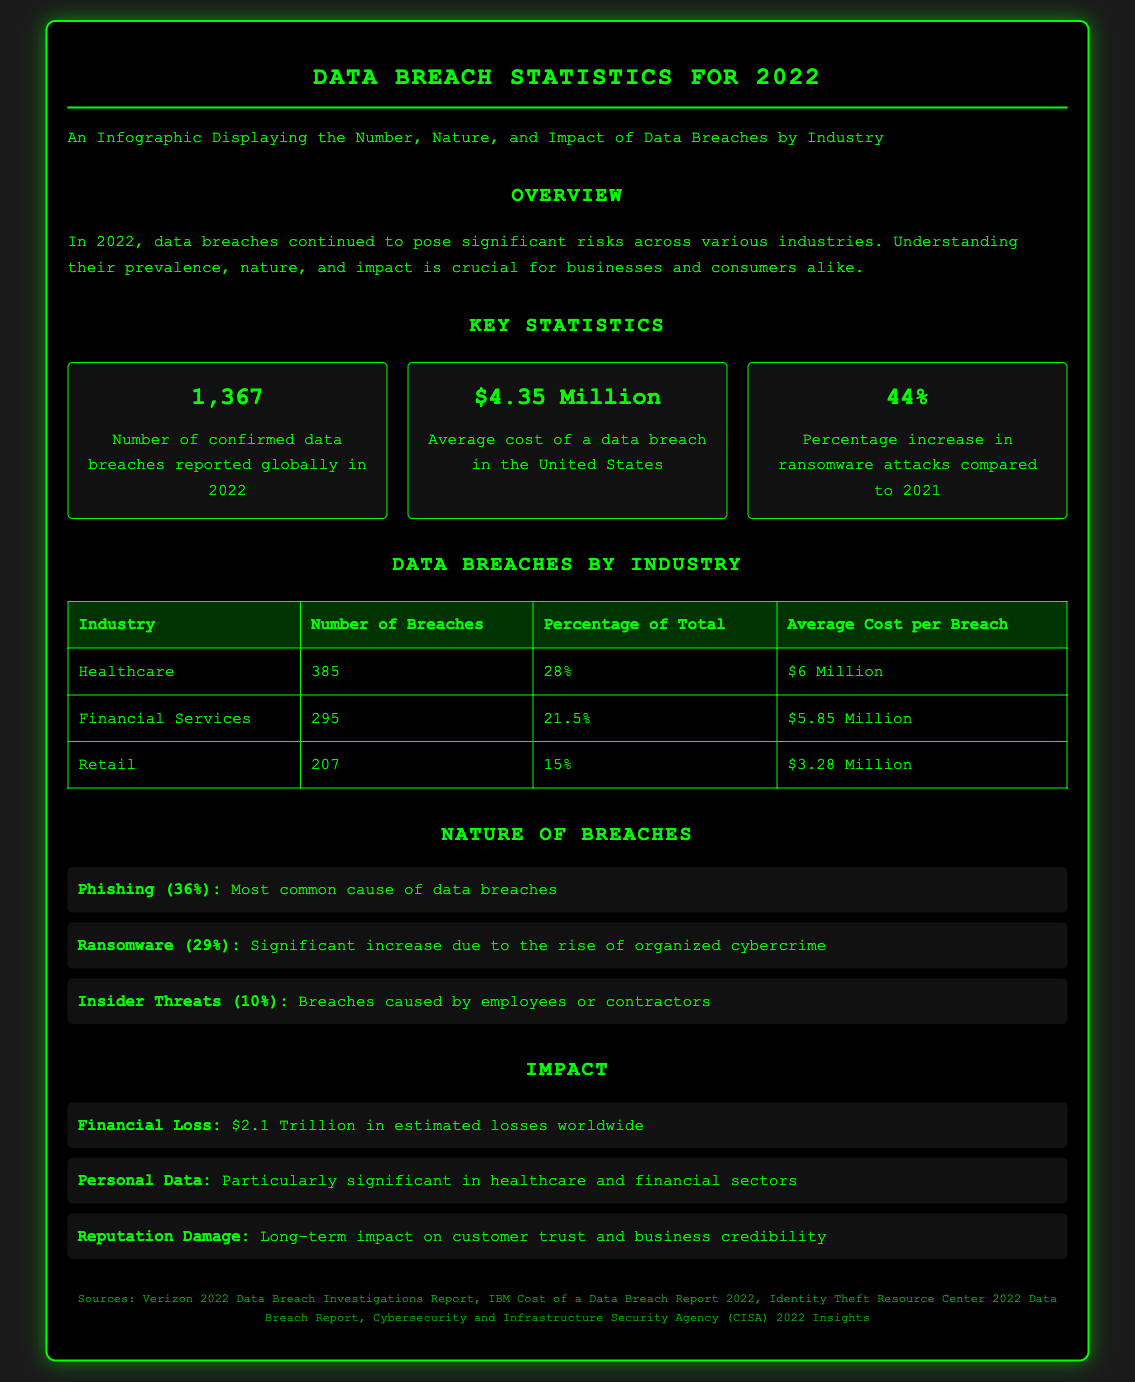What is the number of confirmed data breaches reported globally in 2022? The document states that there were 1,367 confirmed data breaches reported globally in 2022.
Answer: 1,367 What was the average cost of a data breach in the United States? The document mentions that the average cost of a data breach in the United States was $4.35 Million.
Answer: $4.35 Million Which industry had the highest number of data breaches? According to the document, the healthcare industry had the highest number of data breaches, with 385 breaches.
Answer: Healthcare What percentage of the total breaches did the financial services industry represent? The document indicates that financial services represented 21.5% of total breaches, as listed in the data breaches by industry table.
Answer: 21.5% What is the most common cause of data breaches? The document states that phishing is the most common cause, accounting for 36% of breaches.
Answer: Phishing What is the estimated financial loss worldwide due to data breaches? The document provides an estimate of $2.1 Trillion in financial loss worldwide related to data breaches.
Answer: $2.1 Trillion Which two types of breaches showed significant increases according to the document? The document notes significant increases in phishing and ransomware attacks.
Answer: Phishing and Ransomware What long-term impact do data breaches have on businesses? The document mentions that data breaches have a long-term impact on customer trust and business credibility.
Answer: Reputation Damage What was the percentage increase in ransomware attacks compared to 2021? The document reports a 44% increase in ransomware attacks compared to 2021.
Answer: 44% 